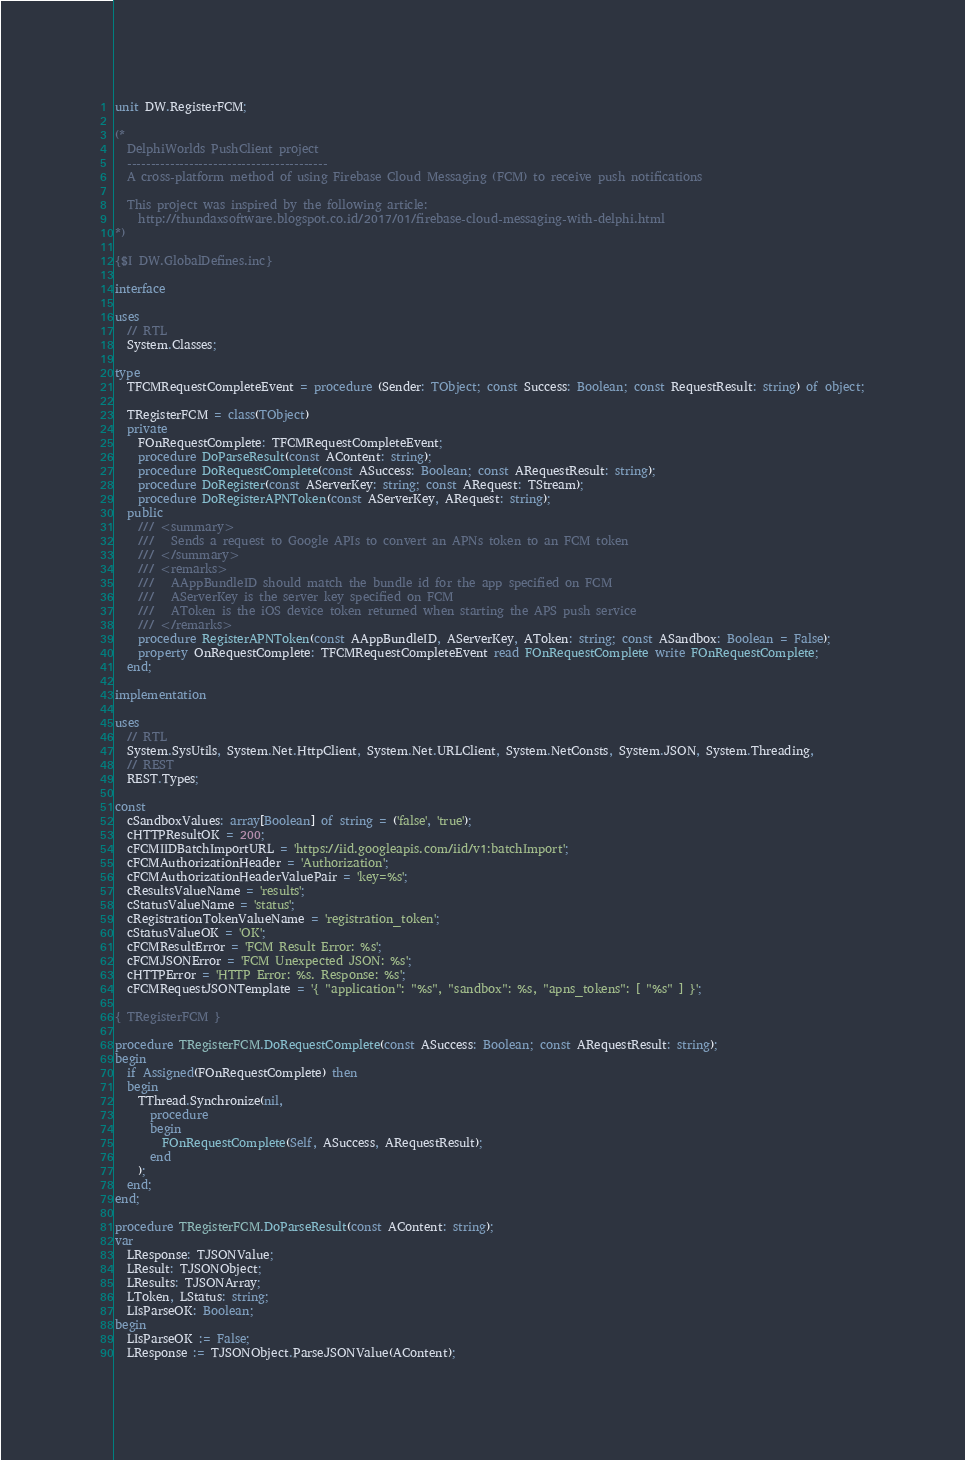<code> <loc_0><loc_0><loc_500><loc_500><_Pascal_>unit DW.RegisterFCM;

(*
  DelphiWorlds PushClient project
  ------------------------------------------
  A cross-platform method of using Firebase Cloud Messaging (FCM) to receive push notifications

  This project was inspired by the following article:
    http://thundaxsoftware.blogspot.co.id/2017/01/firebase-cloud-messaging-with-delphi.html
*)

{$I DW.GlobalDefines.inc}

interface

uses
  // RTL
  System.Classes;

type
  TFCMRequestCompleteEvent = procedure (Sender: TObject; const Success: Boolean; const RequestResult: string) of object;

  TRegisterFCM = class(TObject)
  private
    FOnRequestComplete: TFCMRequestCompleteEvent;
    procedure DoParseResult(const AContent: string);
    procedure DoRequestComplete(const ASuccess: Boolean; const ARequestResult: string);
    procedure DoRegister(const AServerKey: string; const ARequest: TStream);
    procedure DoRegisterAPNToken(const AServerKey, ARequest: string);
  public
    /// <summary>
    ///   Sends a request to Google APIs to convert an APNs token to an FCM token
    /// </summary>
    /// <remarks>
    ///   AAppBundleID should match the bundle id for the app specified on FCM
    ///   AServerKey is the server key specified on FCM
    ///   AToken is the iOS device token returned when starting the APS push service
    /// </remarks>
    procedure RegisterAPNToken(const AAppBundleID, AServerKey, AToken: string; const ASandbox: Boolean = False);
    property OnRequestComplete: TFCMRequestCompleteEvent read FOnRequestComplete write FOnRequestComplete;
  end;

implementation

uses
  // RTL
  System.SysUtils, System.Net.HttpClient, System.Net.URLClient, System.NetConsts, System.JSON, System.Threading,
  // REST
  REST.Types;

const
  cSandboxValues: array[Boolean] of string = ('false', 'true');
  cHTTPResultOK = 200;
  cFCMIIDBatchImportURL = 'https://iid.googleapis.com/iid/v1:batchImport';
  cFCMAuthorizationHeader = 'Authorization';
  cFCMAuthorizationHeaderValuePair = 'key=%s';
  cResultsValueName = 'results';
  cStatusValueName = 'status';
  cRegistrationTokenValueName = 'registration_token';
  cStatusValueOK = 'OK';
  cFCMResultError = 'FCM Result Error: %s';
  cFCMJSONError = 'FCM Unexpected JSON: %s';
  cHTTPError = 'HTTP Error: %s. Response: %s';
  cFCMRequestJSONTemplate = '{ "application": "%s", "sandbox": %s, "apns_tokens": [ "%s" ] }';

{ TRegisterFCM }

procedure TRegisterFCM.DoRequestComplete(const ASuccess: Boolean; const ARequestResult: string);
begin
  if Assigned(FOnRequestComplete) then
  begin
    TThread.Synchronize(nil,
      procedure
      begin
        FOnRequestComplete(Self, ASuccess, ARequestResult);
      end
    );
  end;
end;

procedure TRegisterFCM.DoParseResult(const AContent: string);
var
  LResponse: TJSONValue;
  LResult: TJSONObject;
  LResults: TJSONArray;
  LToken, LStatus: string;
  LIsParseOK: Boolean;
begin
  LIsParseOK := False;
  LResponse := TJSONObject.ParseJSONValue(AContent);</code> 